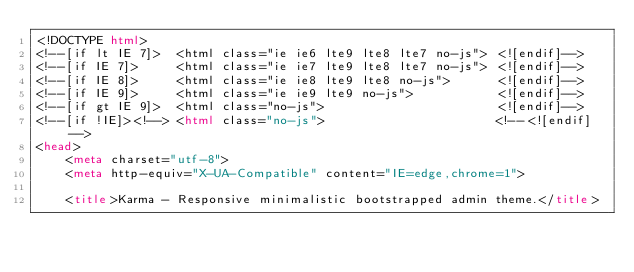<code> <loc_0><loc_0><loc_500><loc_500><_HTML_><!DOCTYPE html>
<!--[if lt IE 7]>  <html class="ie ie6 lte9 lte8 lte7 no-js"> <![endif]-->
<!--[if IE 7]>     <html class="ie ie7 lte9 lte8 lte7 no-js"> <![endif]-->
<!--[if IE 8]>     <html class="ie ie8 lte9 lte8 no-js">      <![endif]-->
<!--[if IE 9]>     <html class="ie ie9 lte9 no-js">           <![endif]-->
<!--[if gt IE 9]>  <html class="no-js">                       <![endif]-->
<!--[if !IE]><!--> <html class="no-js">                       <!--<![endif]-->
<head>
    <meta charset="utf-8">
    <meta http-equiv="X-UA-Compatible" content="IE=edge,chrome=1">

    <title>Karma - Responsive minimalistic bootstrapped admin theme.</title></code> 